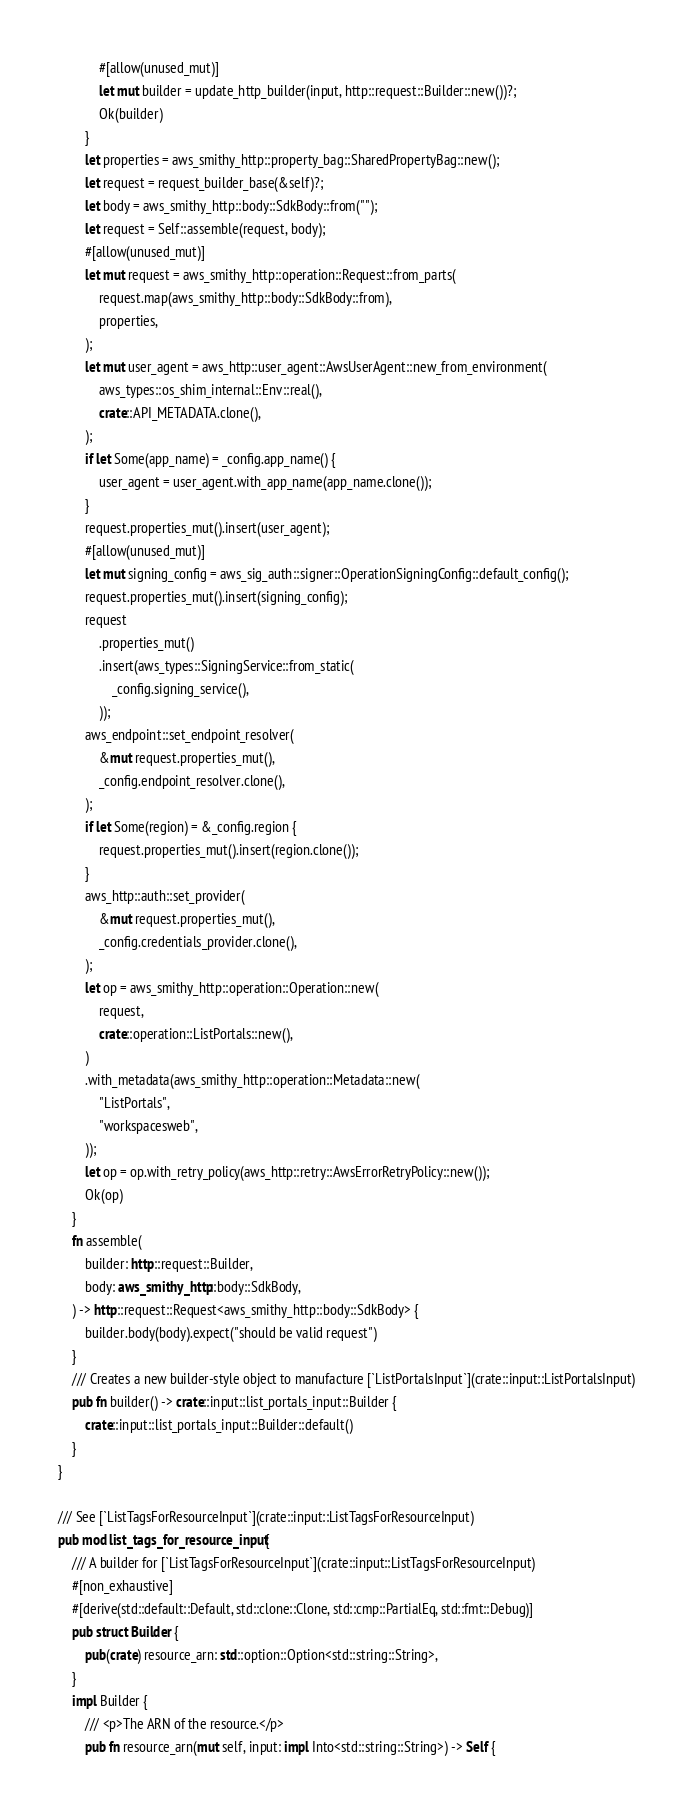Convert code to text. <code><loc_0><loc_0><loc_500><loc_500><_Rust_>            #[allow(unused_mut)]
            let mut builder = update_http_builder(input, http::request::Builder::new())?;
            Ok(builder)
        }
        let properties = aws_smithy_http::property_bag::SharedPropertyBag::new();
        let request = request_builder_base(&self)?;
        let body = aws_smithy_http::body::SdkBody::from("");
        let request = Self::assemble(request, body);
        #[allow(unused_mut)]
        let mut request = aws_smithy_http::operation::Request::from_parts(
            request.map(aws_smithy_http::body::SdkBody::from),
            properties,
        );
        let mut user_agent = aws_http::user_agent::AwsUserAgent::new_from_environment(
            aws_types::os_shim_internal::Env::real(),
            crate::API_METADATA.clone(),
        );
        if let Some(app_name) = _config.app_name() {
            user_agent = user_agent.with_app_name(app_name.clone());
        }
        request.properties_mut().insert(user_agent);
        #[allow(unused_mut)]
        let mut signing_config = aws_sig_auth::signer::OperationSigningConfig::default_config();
        request.properties_mut().insert(signing_config);
        request
            .properties_mut()
            .insert(aws_types::SigningService::from_static(
                _config.signing_service(),
            ));
        aws_endpoint::set_endpoint_resolver(
            &mut request.properties_mut(),
            _config.endpoint_resolver.clone(),
        );
        if let Some(region) = &_config.region {
            request.properties_mut().insert(region.clone());
        }
        aws_http::auth::set_provider(
            &mut request.properties_mut(),
            _config.credentials_provider.clone(),
        );
        let op = aws_smithy_http::operation::Operation::new(
            request,
            crate::operation::ListPortals::new(),
        )
        .with_metadata(aws_smithy_http::operation::Metadata::new(
            "ListPortals",
            "workspacesweb",
        ));
        let op = op.with_retry_policy(aws_http::retry::AwsErrorRetryPolicy::new());
        Ok(op)
    }
    fn assemble(
        builder: http::request::Builder,
        body: aws_smithy_http::body::SdkBody,
    ) -> http::request::Request<aws_smithy_http::body::SdkBody> {
        builder.body(body).expect("should be valid request")
    }
    /// Creates a new builder-style object to manufacture [`ListPortalsInput`](crate::input::ListPortalsInput)
    pub fn builder() -> crate::input::list_portals_input::Builder {
        crate::input::list_portals_input::Builder::default()
    }
}

/// See [`ListTagsForResourceInput`](crate::input::ListTagsForResourceInput)
pub mod list_tags_for_resource_input {
    /// A builder for [`ListTagsForResourceInput`](crate::input::ListTagsForResourceInput)
    #[non_exhaustive]
    #[derive(std::default::Default, std::clone::Clone, std::cmp::PartialEq, std::fmt::Debug)]
    pub struct Builder {
        pub(crate) resource_arn: std::option::Option<std::string::String>,
    }
    impl Builder {
        /// <p>The ARN of the resource.</p>
        pub fn resource_arn(mut self, input: impl Into<std::string::String>) -> Self {</code> 